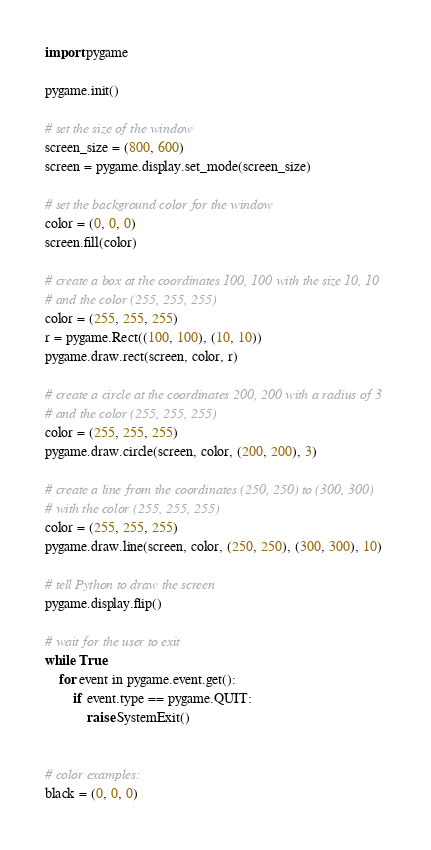Convert code to text. <code><loc_0><loc_0><loc_500><loc_500><_Python_>import pygame

pygame.init()

# set the size of the window
screen_size = (800, 600)
screen = pygame.display.set_mode(screen_size)

# set the background color for the window
color = (0, 0, 0)
screen.fill(color)

# create a box at the coordinates 100, 100 with the size 10, 10
# and the color (255, 255, 255)
color = (255, 255, 255)
r = pygame.Rect((100, 100), (10, 10))
pygame.draw.rect(screen, color, r)

# create a circle at the coordinates 200, 200 with a radius of 3
# and the color (255, 255, 255)
color = (255, 255, 255)
pygame.draw.circle(screen, color, (200, 200), 3)

# create a line from the coordinates (250, 250) to (300, 300)
# with the color (255, 255, 255)
color = (255, 255, 255)
pygame.draw.line(screen, color, (250, 250), (300, 300), 10)

# tell Python to draw the screen
pygame.display.flip()

# wait for the user to exit
while True:
    for event in pygame.event.get():
        if event.type == pygame.QUIT:
            raise SystemExit()


# color examples:
black = (0, 0, 0)</code> 